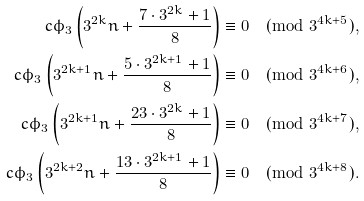<formula> <loc_0><loc_0><loc_500><loc_500>c \phi _ { 3 } \left ( 3 ^ { 2 k } n + \frac { 7 \cdot 3 ^ { 2 k } + 1 } { 8 } \right ) & \equiv 0 \pmod { 3 ^ { 4 k + 5 } } , \\ c \phi _ { 3 } \left ( 3 ^ { 2 k + 1 } n + \frac { 5 \cdot 3 ^ { 2 k + 1 } + 1 } { 8 } \right ) & \equiv 0 \pmod { 3 ^ { 4 k + 6 } } , \\ c \phi _ { 3 } \left ( 3 ^ { 2 k + 1 } n + \frac { 2 3 \cdot 3 ^ { 2 k } + 1 } { 8 } \right ) & \equiv 0 \pmod { 3 ^ { 4 k + 7 } } , \\ c \phi _ { 3 } \left ( 3 ^ { 2 k + 2 } n + \frac { 1 3 \cdot 3 ^ { 2 k + 1 } + 1 } { 8 } \right ) & \equiv 0 \pmod { 3 ^ { 4 k + 8 } } .</formula> 